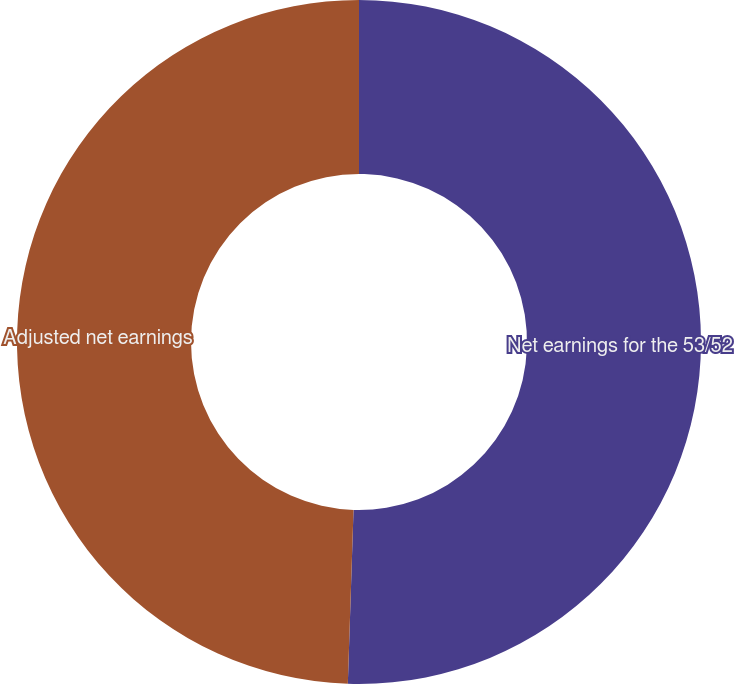Convert chart to OTSL. <chart><loc_0><loc_0><loc_500><loc_500><pie_chart><fcel>Net earnings for the 53/52<fcel>Adjusted net earnings<nl><fcel>50.52%<fcel>49.48%<nl></chart> 